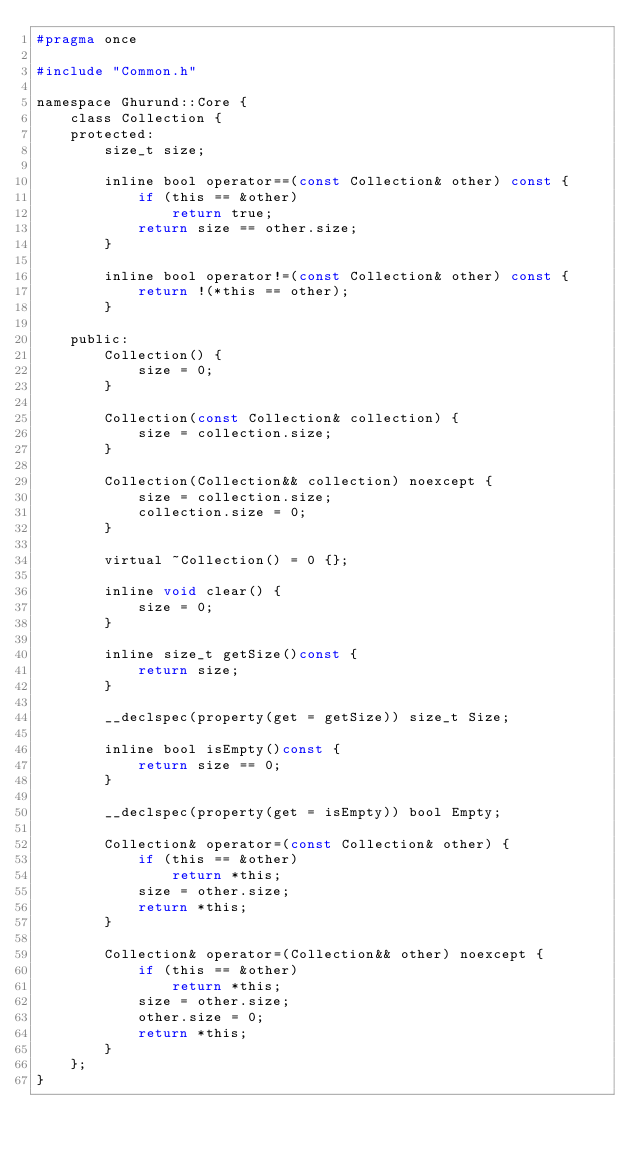<code> <loc_0><loc_0><loc_500><loc_500><_C_>#pragma once

#include "Common.h"

namespace Ghurund::Core {
    class Collection {
    protected:
        size_t size;

        inline bool operator==(const Collection& other) const {
            if (this == &other)
                return true;
            return size == other.size;
        }

        inline bool operator!=(const Collection& other) const {
            return !(*this == other);
        }

    public:
        Collection() {
            size = 0;
        }

        Collection(const Collection& collection) {
            size = collection.size;
        }

        Collection(Collection&& collection) noexcept {
            size = collection.size;
            collection.size = 0;
        }

        virtual ~Collection() = 0 {};

        inline void clear() {
            size = 0;
        }

        inline size_t getSize()const {
            return size;
        }

        __declspec(property(get = getSize)) size_t Size;

        inline bool isEmpty()const {
            return size == 0;
        }

        __declspec(property(get = isEmpty)) bool Empty;

        Collection& operator=(const Collection& other) {
            if (this == &other)
                return *this;
            size = other.size;
            return *this;
        }

        Collection& operator=(Collection&& other) noexcept {
            if (this == &other)
                return *this;
            size = other.size;
            other.size = 0;
            return *this;
        }
    };
}
</code> 